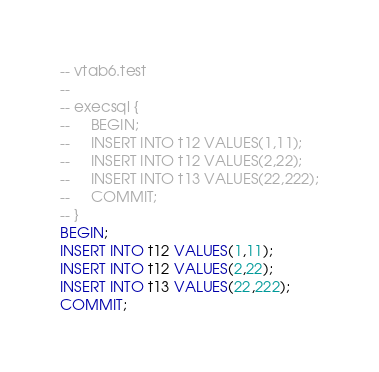Convert code to text. <code><loc_0><loc_0><loc_500><loc_500><_SQL_>-- vtab6.test
-- 
-- execsql {
--     BEGIN;
--     INSERT INTO t12 VALUES(1,11);
--     INSERT INTO t12 VALUES(2,22);
--     INSERT INTO t13 VALUES(22,222);
--     COMMIT;
-- }
BEGIN;
INSERT INTO t12 VALUES(1,11);
INSERT INTO t12 VALUES(2,22);
INSERT INTO t13 VALUES(22,222);
COMMIT;</code> 